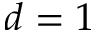Convert formula to latex. <formula><loc_0><loc_0><loc_500><loc_500>d = 1</formula> 